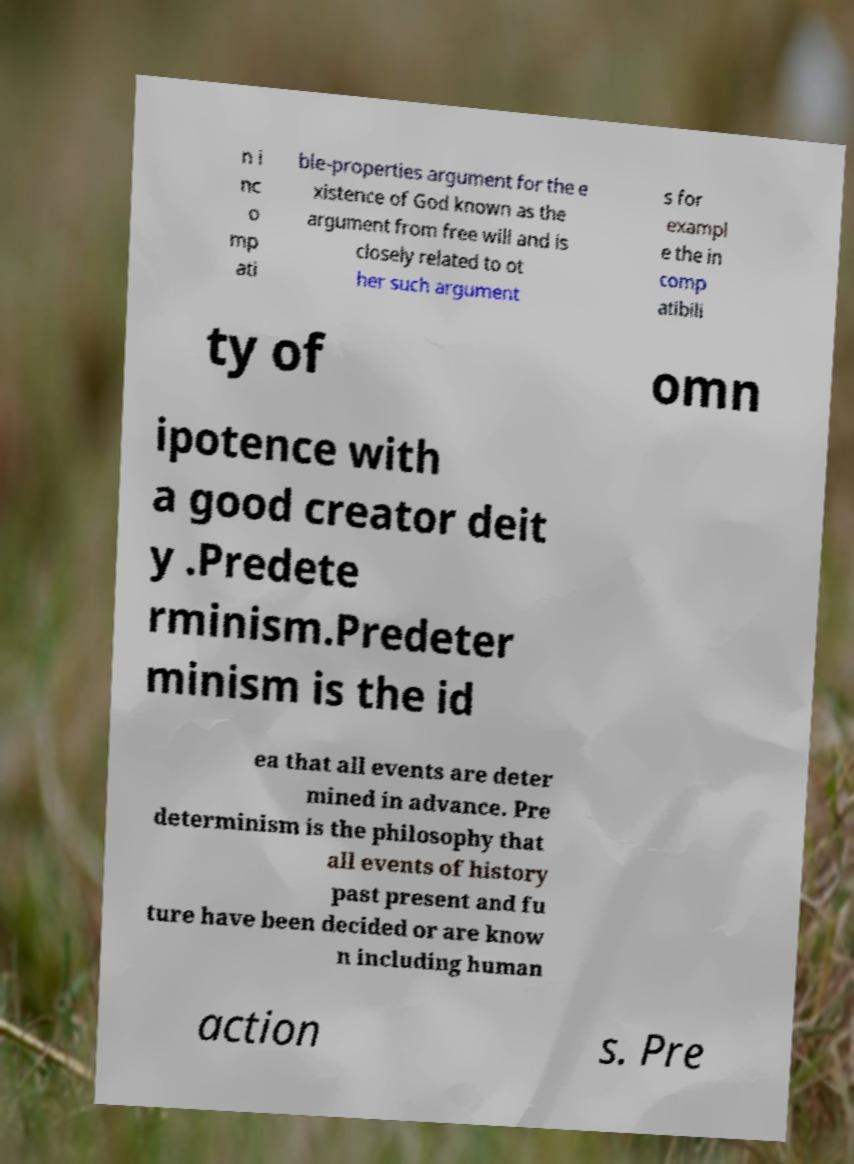I need the written content from this picture converted into text. Can you do that? n i nc o mp ati ble-properties argument for the e xistence of God known as the argument from free will and is closely related to ot her such argument s for exampl e the in comp atibili ty of omn ipotence with a good creator deit y .Predete rminism.Predeter minism is the id ea that all events are deter mined in advance. Pre determinism is the philosophy that all events of history past present and fu ture have been decided or are know n including human action s. Pre 